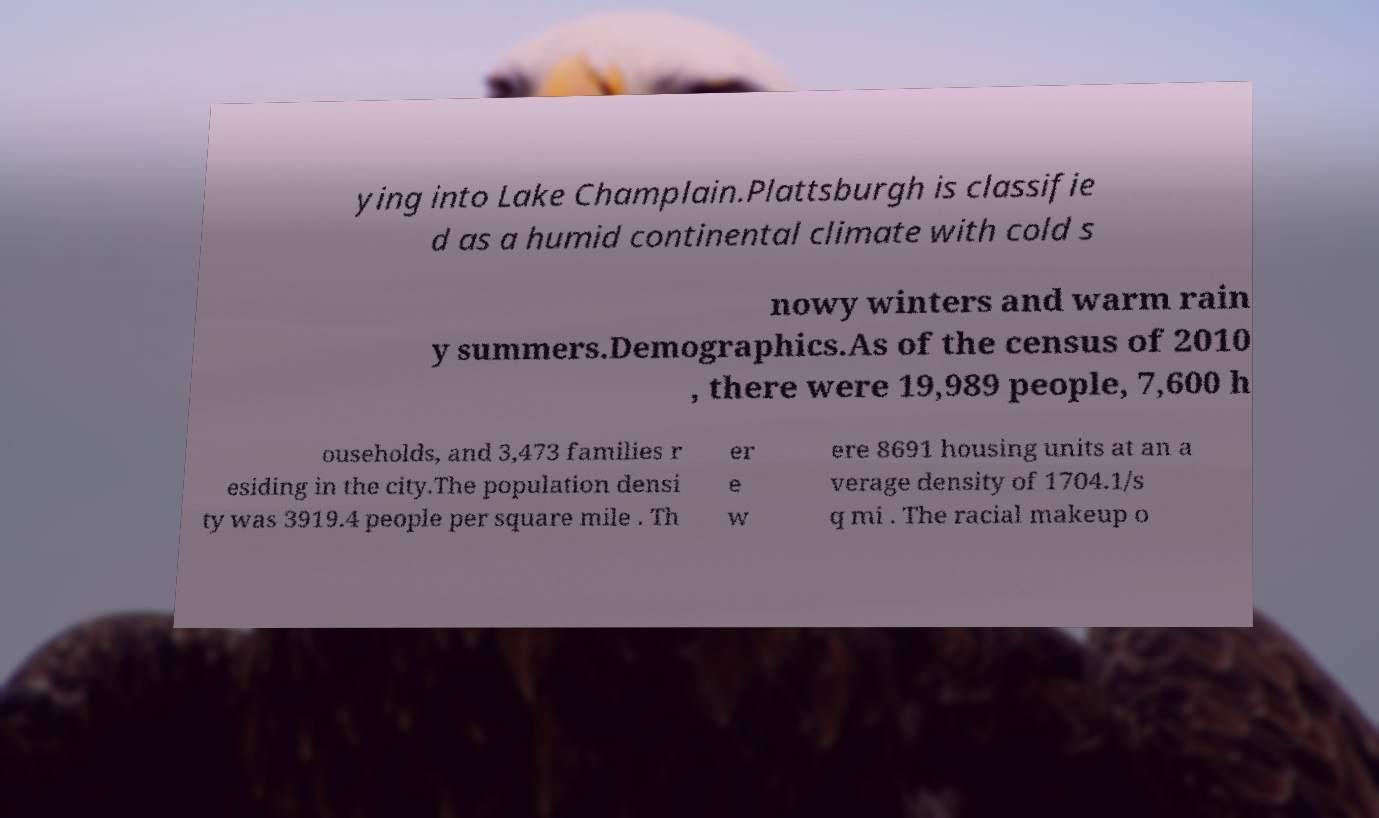Can you accurately transcribe the text from the provided image for me? ying into Lake Champlain.Plattsburgh is classifie d as a humid continental climate with cold s nowy winters and warm rain y summers.Demographics.As of the census of 2010 , there were 19,989 people, 7,600 h ouseholds, and 3,473 families r esiding in the city.The population densi ty was 3919.4 people per square mile . Th er e w ere 8691 housing units at an a verage density of 1704.1/s q mi . The racial makeup o 